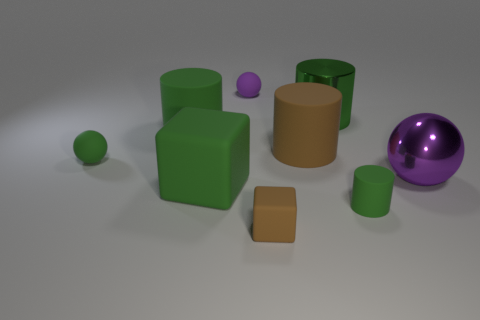There is a small green object right of the purple matte ball; what material is it? The small green object has a smooth, somewhat shiny surface suggesting that it is likely made of plastic, a common material for objects in a similar setting. Its sheen and lack of texture contrasts with the matte finish of the nearby purple ball, distinguishing their materials. 